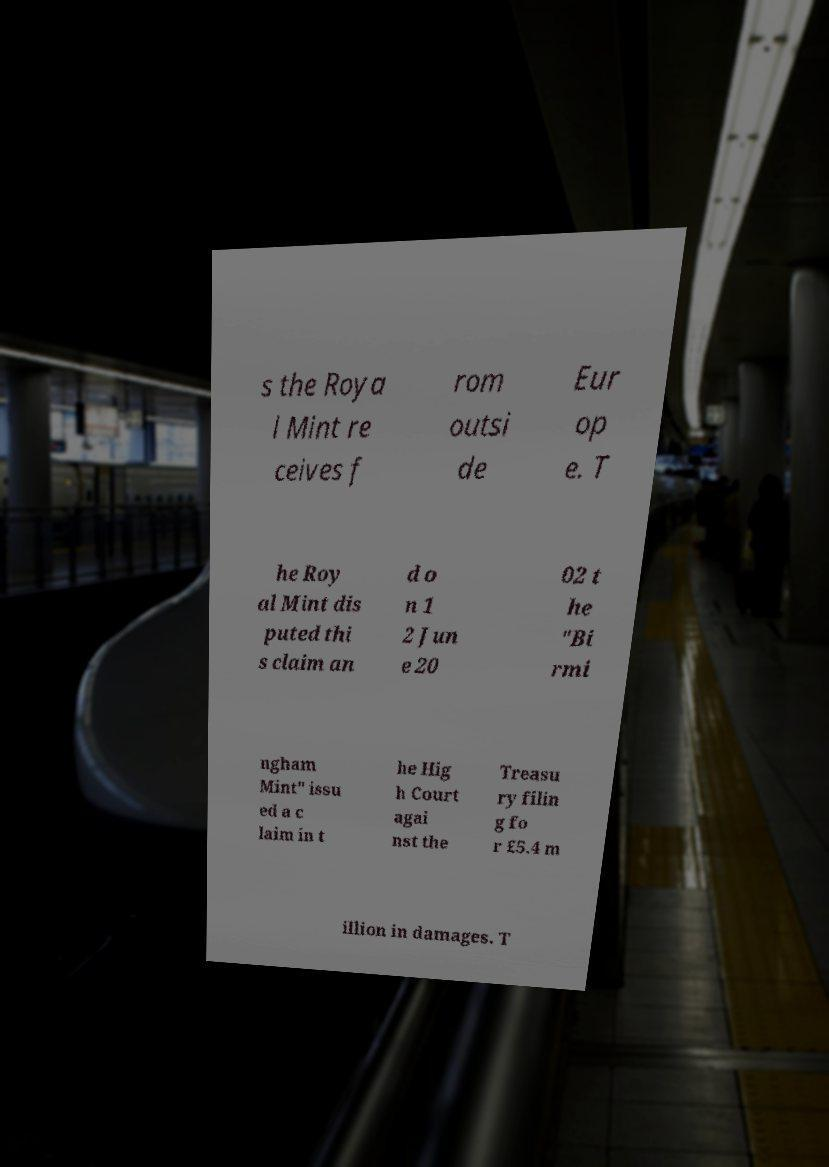For documentation purposes, I need the text within this image transcribed. Could you provide that? s the Roya l Mint re ceives f rom outsi de Eur op e. T he Roy al Mint dis puted thi s claim an d o n 1 2 Jun e 20 02 t he "Bi rmi ngham Mint" issu ed a c laim in t he Hig h Court agai nst the Treasu ry filin g fo r £5.4 m illion in damages. T 